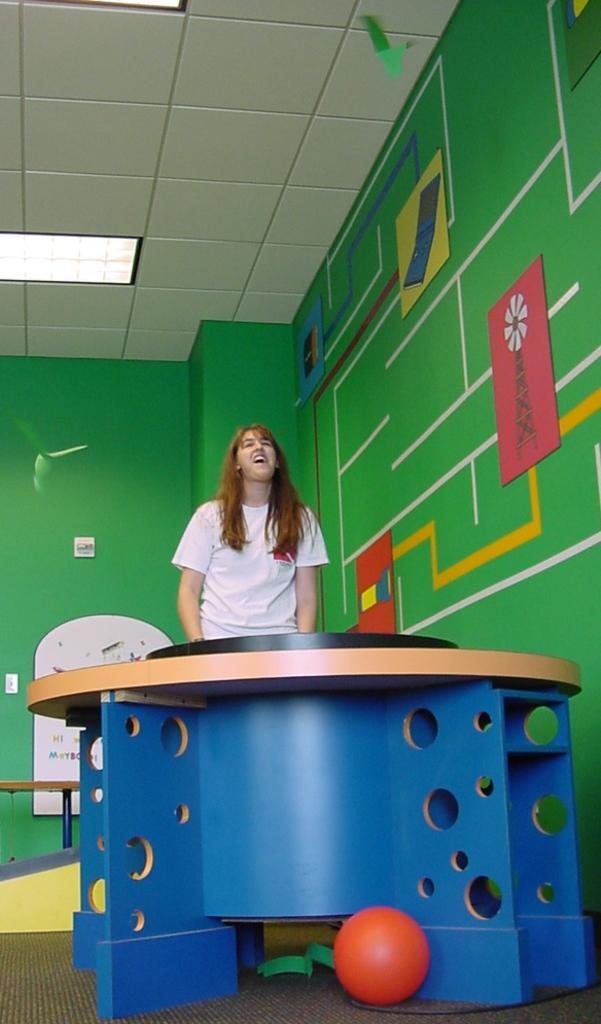Can you describe this image briefly? In this image i can see woman standing there is a table and ball in front of her at the background there is a wall. 